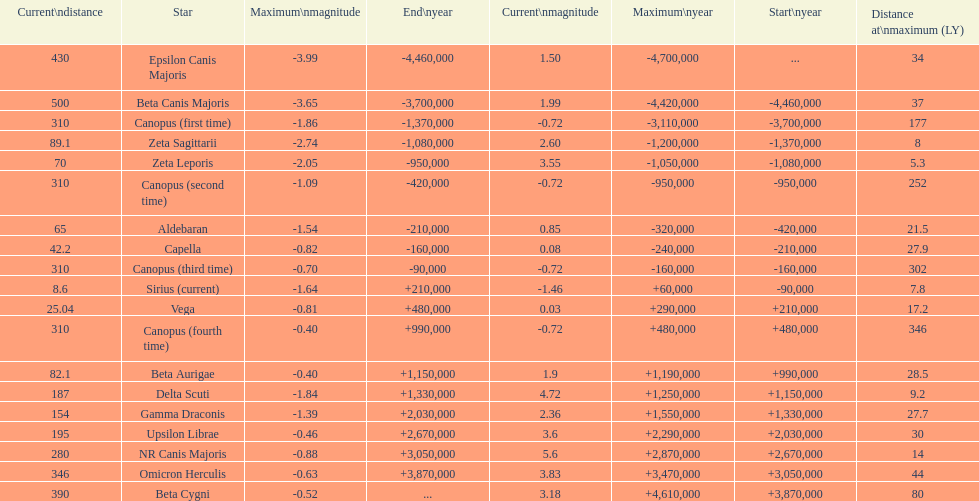Could you parse the entire table as a dict? {'header': ['Current\\ndistance', 'Star', 'Maximum\\nmagnitude', 'End\\nyear', 'Current\\nmagnitude', 'Maximum\\nyear', 'Start\\nyear', 'Distance at\\nmaximum (LY)'], 'rows': [['430', 'Epsilon Canis Majoris', '-3.99', '-4,460,000', '1.50', '-4,700,000', '...', '34'], ['500', 'Beta Canis Majoris', '-3.65', '-3,700,000', '1.99', '-4,420,000', '-4,460,000', '37'], ['310', 'Canopus (first time)', '-1.86', '-1,370,000', '-0.72', '-3,110,000', '-3,700,000', '177'], ['89.1', 'Zeta Sagittarii', '-2.74', '-1,080,000', '2.60', '-1,200,000', '-1,370,000', '8'], ['70', 'Zeta Leporis', '-2.05', '-950,000', '3.55', '-1,050,000', '-1,080,000', '5.3'], ['310', 'Canopus (second time)', '-1.09', '-420,000', '-0.72', '-950,000', '-950,000', '252'], ['65', 'Aldebaran', '-1.54', '-210,000', '0.85', '-320,000', '-420,000', '21.5'], ['42.2', 'Capella', '-0.82', '-160,000', '0.08', '-240,000', '-210,000', '27.9'], ['310', 'Canopus (third time)', '-0.70', '-90,000', '-0.72', '-160,000', '-160,000', '302'], ['8.6', 'Sirius (current)', '-1.64', '+210,000', '-1.46', '+60,000', '-90,000', '7.8'], ['25.04', 'Vega', '-0.81', '+480,000', '0.03', '+290,000', '+210,000', '17.2'], ['310', 'Canopus (fourth time)', '-0.40', '+990,000', '-0.72', '+480,000', '+480,000', '346'], ['82.1', 'Beta Aurigae', '-0.40', '+1,150,000', '1.9', '+1,190,000', '+990,000', '28.5'], ['187', 'Delta Scuti', '-1.84', '+1,330,000', '4.72', '+1,250,000', '+1,150,000', '9.2'], ['154', 'Gamma Draconis', '-1.39', '+2,030,000', '2.36', '+1,550,000', '+1,330,000', '27.7'], ['195', 'Upsilon Librae', '-0.46', '+2,670,000', '3.6', '+2,290,000', '+2,030,000', '30'], ['280', 'NR Canis Majoris', '-0.88', '+3,050,000', '5.6', '+2,870,000', '+2,670,000', '14'], ['346', 'Omicron Herculis', '-0.63', '+3,870,000', '3.83', '+3,470,000', '+3,050,000', '44'], ['390', 'Beta Cygni', '-0.52', '...', '3.18', '+4,610,000', '+3,870,000', '80']]} Is capella's current magnitude more than vega's current magnitude? Yes. 